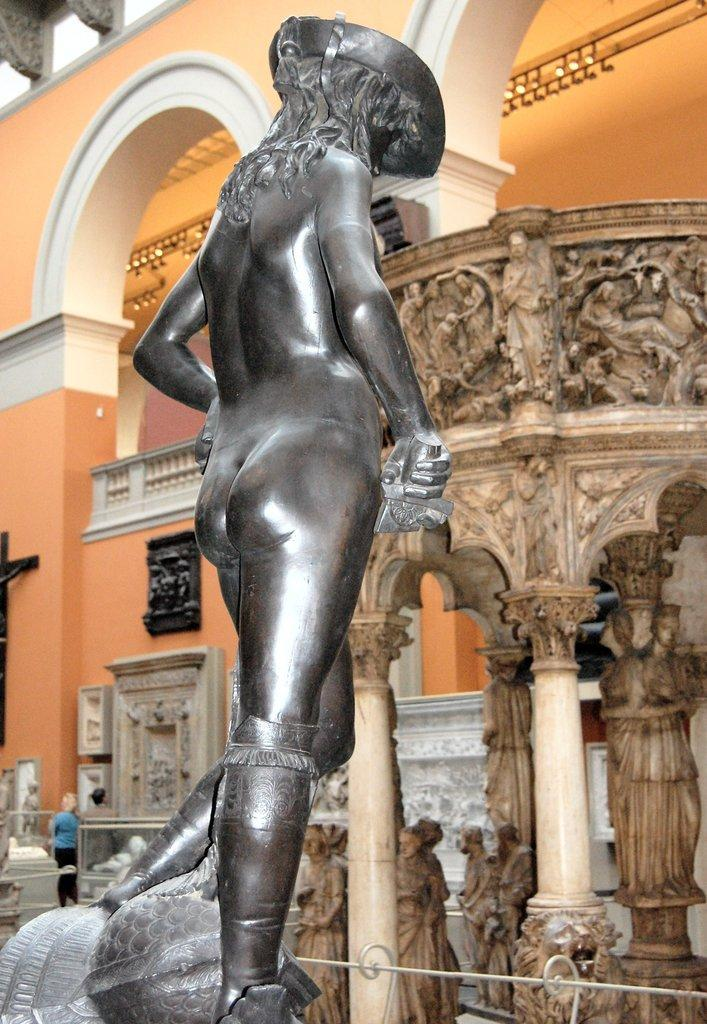What is the main subject in the foreground of the picture? There is there a sculpture in the foreground of the picture? What can be seen in the center of the picture? There are sculptures in the center of the picture. What is happening in the background of the picture? There is construction in the background of the picture. Can you describe the person in the picture? There is a person on the left side of the picture. What type of sweater is the brain wearing in the picture? There is no brain or sweater present in the picture; it features sculptures and a person. How does the spring affect the sculptures in the picture? There is no mention of a spring in the picture; it only shows sculptures, construction, and a person. 